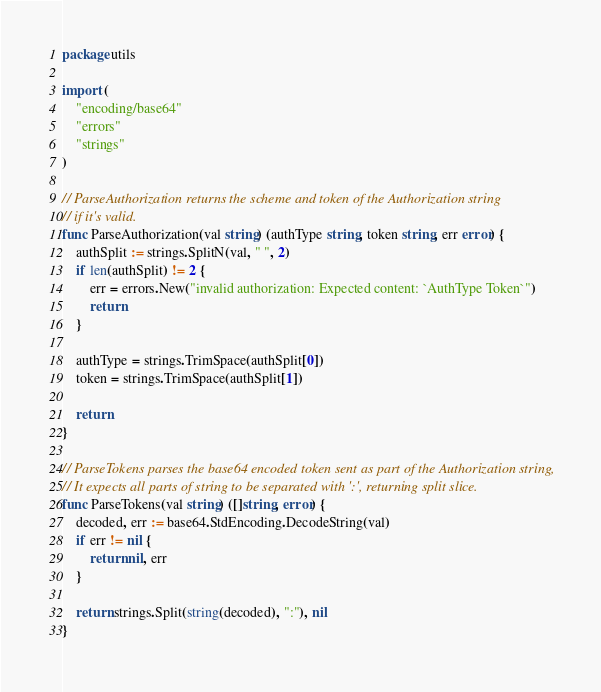<code> <loc_0><loc_0><loc_500><loc_500><_Go_>package utils

import (
	"encoding/base64"
	"errors"
	"strings"
)

// ParseAuthorization returns the scheme and token of the Authorization string
// if it's valid.
func ParseAuthorization(val string) (authType string, token string, err error) {
	authSplit := strings.SplitN(val, " ", 2)
	if len(authSplit) != 2 {
		err = errors.New("invalid authorization: Expected content: `AuthType Token`")
		return
	}

	authType = strings.TrimSpace(authSplit[0])
	token = strings.TrimSpace(authSplit[1])

	return
}

// ParseTokens parses the base64 encoded token sent as part of the Authorization string,
// It expects all parts of string to be separated with ':', returning split slice.
func ParseTokens(val string) ([]string, error) {
	decoded, err := base64.StdEncoding.DecodeString(val)
	if err != nil {
		return nil, err
	}

	return strings.Split(string(decoded), ":"), nil
}
</code> 